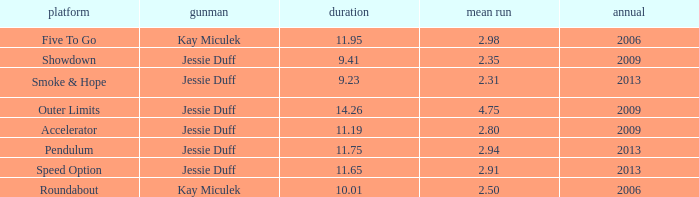What is the total years with average runs less than 4.75 and a time of 14.26? 0.0. 